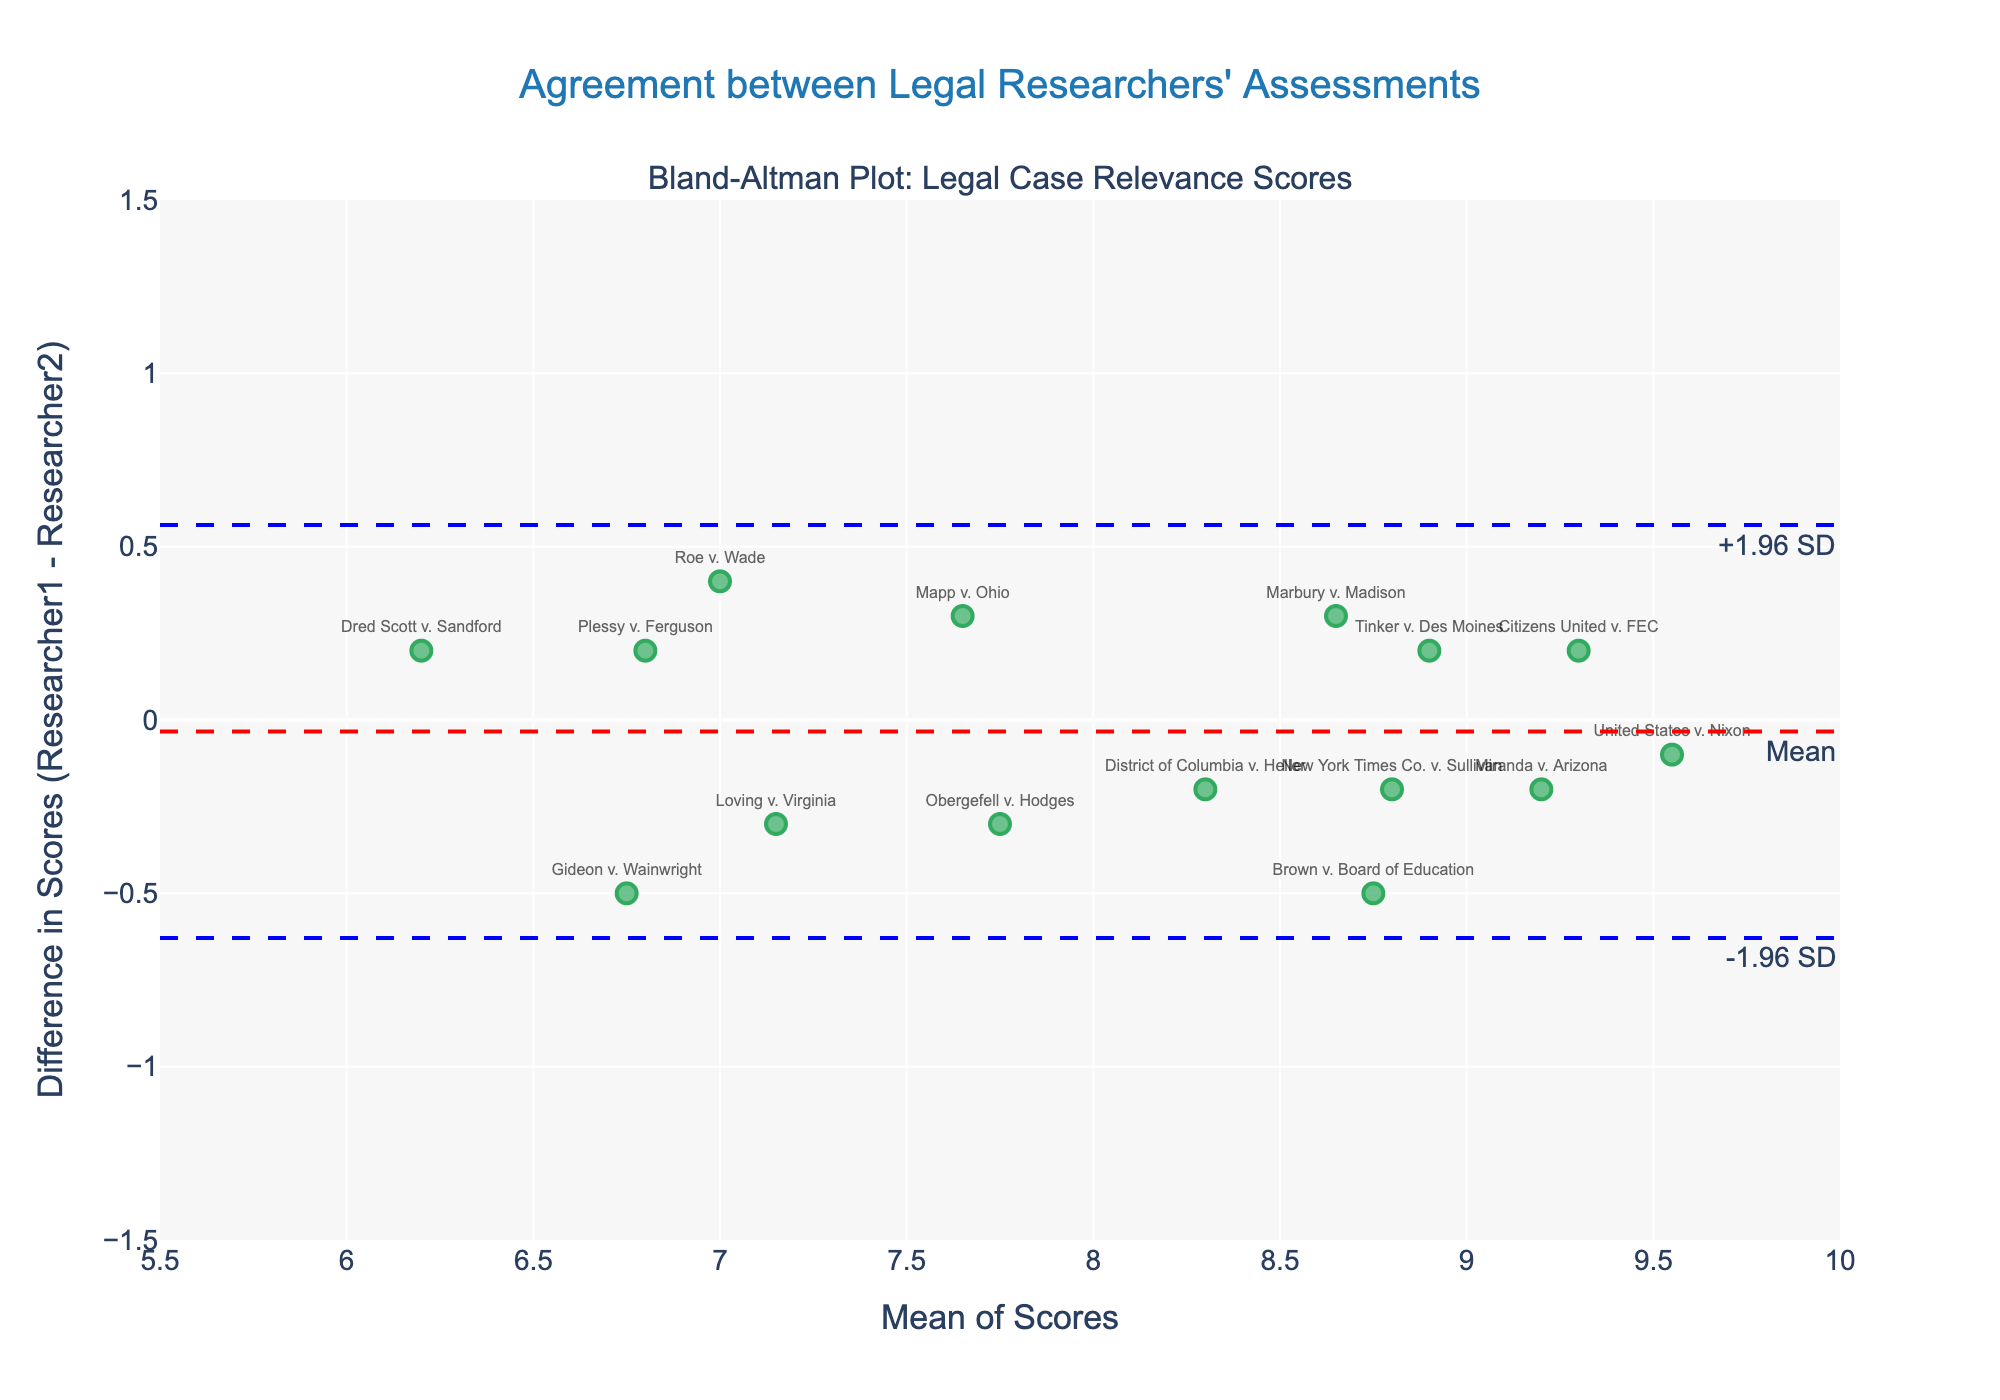What's the title of the plot? The title is displayed at the top of the plot. It reads "Agreement between Legal Researchers' Assessments".
Answer: Agreement between Legal Researchers' Assessments What do the x-axis and y-axis represent? The x-axis represents the "Mean of Scores," which is the average of the relevance scores given by the two researchers. The y-axis represents the "Difference in Scores (Researcher1 - Researcher2)," which is the difference between Researcher1's score and Researcher2's score.
Answer: Mean of Scores, Difference in Scores (Researcher1 - Researcher2) How many data points (cases) are plotted on the graph? Each case is represented by a marker on the graph. By counting them, you see there are 15 cases plotted.
Answer: 15 Which case has the highest mean relevance score? Find the highest value along the x-axis (Mean of Scores). The corresponding point is "United States v. Nixon" with an average score of approximately 9.55.
Answer: United States v. Nixon What is the mean difference between the researchers' scores? Identify the horizontal line labeled "Mean." This line represents the mean difference and is located at approximately 0.04 on the y-axis.
Answer: 0.04 What are the limits of agreement for the researchers' difference scores? Locate the two horizontal lines labeled "-1.96 SD" and "+1.96 SD." These lines represent the lower and upper limits of agreement, approximately at -0.52 and 0.60, respectively.
Answer: -0.52, 0.60 Which case shows the largest difference in scores between the researchers? Identify the point farthest from the "Mean" horizontal line. The "Dred Scott v. Sandford" case shows the largest negative difference, and "Miranda v. Arizona" shows the largest positive difference.
Answer: Dred Scott v. Sandford, Miranda v. Arizona Are there any cases where the researchers completely agreed on the score? Look for points where the "Difference in Scores" (y-axis) is zero. There are no points exactly on the y=0 line, so there are no cases with complete agreement.
Answer: No What is the relevance score of "Roe v. Wade" given by Researcher1 and Researcher2? "Roe v. Wade" can be located with its label. Find its position on the graph and check the corresponding scores. The mean score is approximately 7.0 (x-axis), and the difference is 0.4 (y-axis). Researcher1 gave a score of 7.2, and Researcher2 gave a score of 6.8.
Answer: 7.2, 6.8 